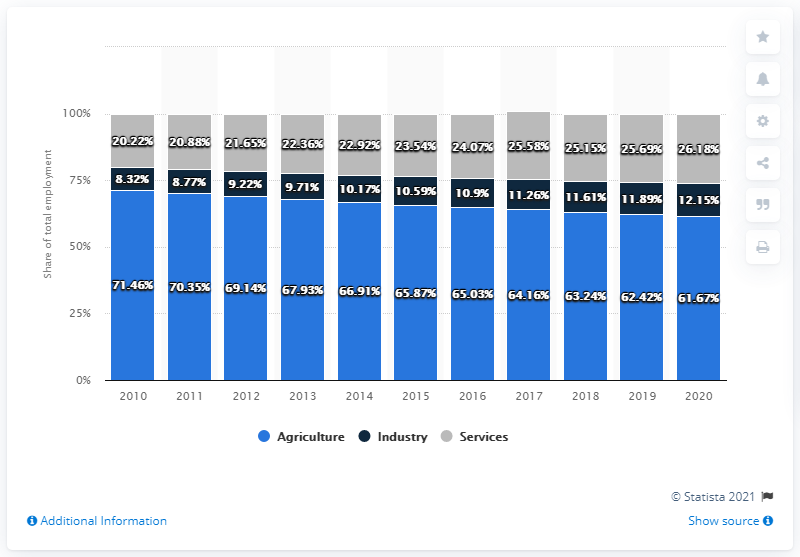Highlight a few significant elements in this photo. The leftmost light bar has a value of 71.46... The distribution of services from employment and services in 2017 was 14.32%. 